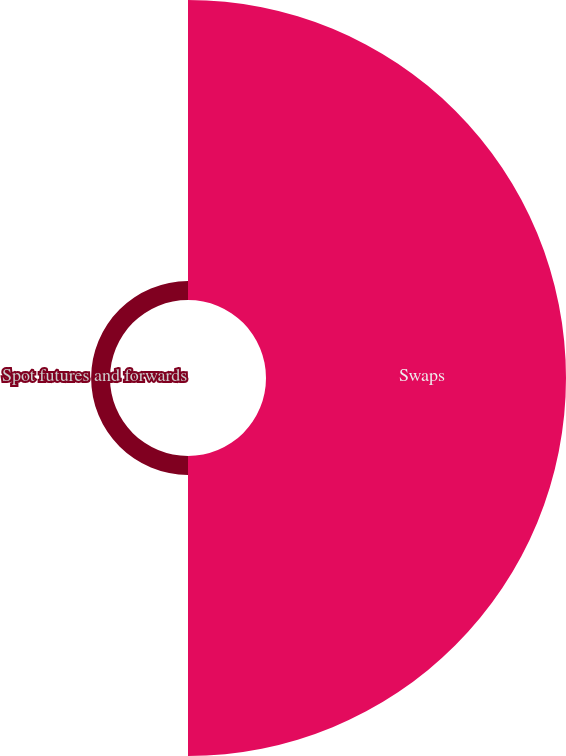Convert chart. <chart><loc_0><loc_0><loc_500><loc_500><pie_chart><fcel>Swaps<fcel>Spot futures and forwards<nl><fcel>94.08%<fcel>5.92%<nl></chart> 